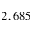<formula> <loc_0><loc_0><loc_500><loc_500>2 , 6 8 5</formula> 